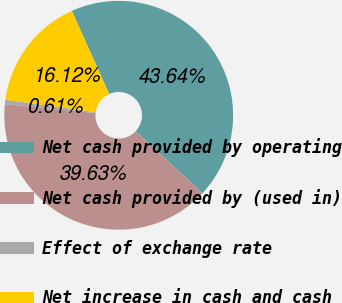Convert chart to OTSL. <chart><loc_0><loc_0><loc_500><loc_500><pie_chart><fcel>Net cash provided by operating<fcel>Net cash provided by (used in)<fcel>Effect of exchange rate<fcel>Net increase in cash and cash<nl><fcel>43.64%<fcel>39.63%<fcel>0.61%<fcel>16.12%<nl></chart> 